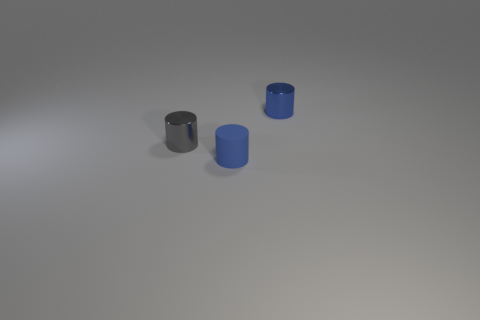There is a blue object that is made of the same material as the gray object; what size is it?
Your answer should be compact. Small. There is a metallic cylinder that is the same color as the matte object; what size is it?
Provide a short and direct response. Small. What number of other objects are there of the same size as the gray cylinder?
Your response must be concise. 2. There is a small cylinder that is in front of the gray object; what is its material?
Make the answer very short. Rubber. The shiny thing that is on the right side of the metal object that is left of the tiny blue thing behind the tiny gray object is what shape?
Ensure brevity in your answer.  Cylinder. Is the gray cylinder the same size as the blue shiny thing?
Provide a succinct answer. Yes. What number of objects are brown matte things or small gray cylinders to the left of the blue metal thing?
Offer a terse response. 1. How many objects are small metal objects that are behind the small gray shiny cylinder or small cylinders that are in front of the small blue metallic cylinder?
Your answer should be compact. 3. Are there any objects in front of the gray metallic cylinder?
Your answer should be very brief. Yes. The small metallic thing that is behind the tiny object that is on the left side of the object that is in front of the gray cylinder is what color?
Keep it short and to the point. Blue. 